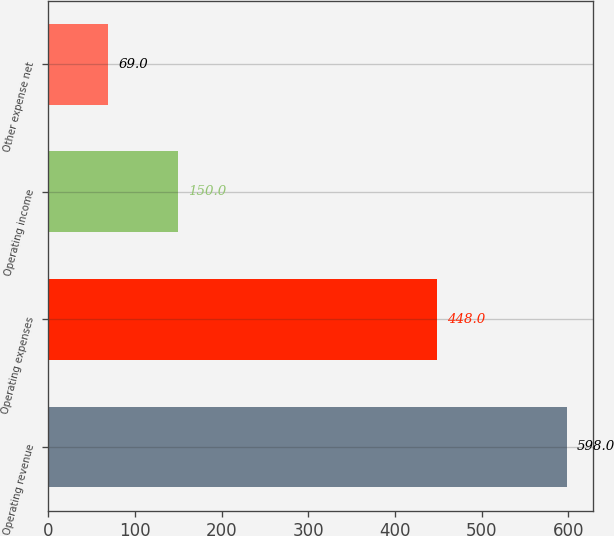<chart> <loc_0><loc_0><loc_500><loc_500><bar_chart><fcel>Operating revenue<fcel>Operating expenses<fcel>Operating income<fcel>Other expense net<nl><fcel>598<fcel>448<fcel>150<fcel>69<nl></chart> 